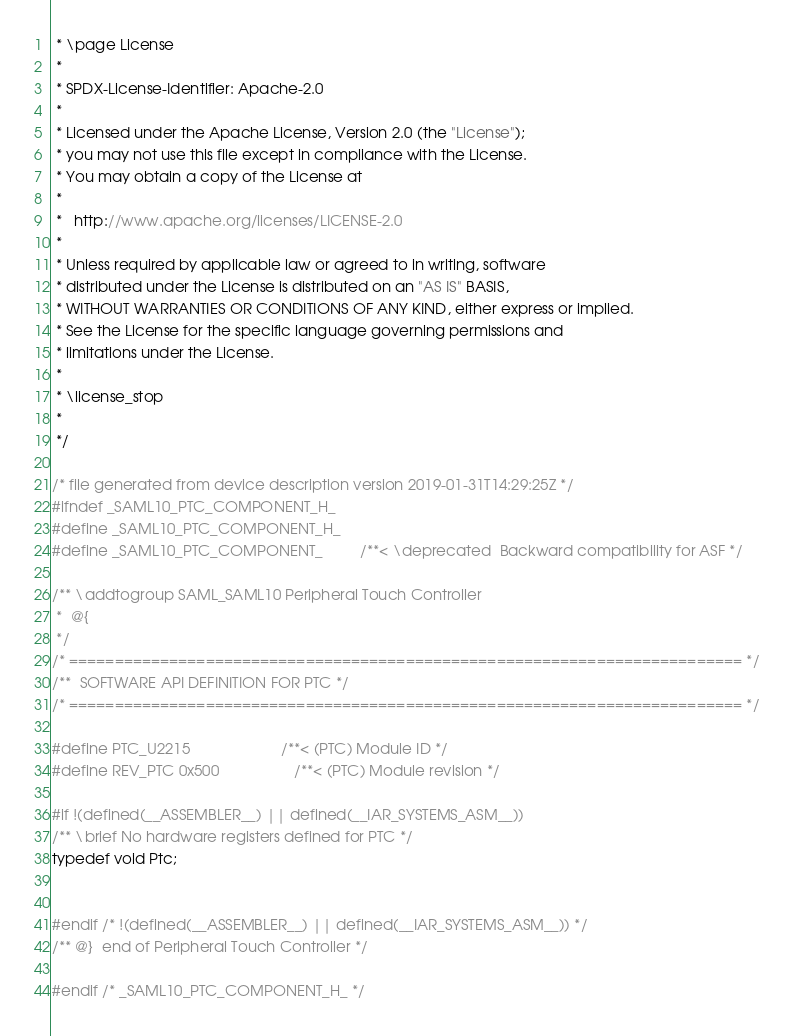Convert code to text. <code><loc_0><loc_0><loc_500><loc_500><_C_> * \page License
 *
 * SPDX-License-Identifier: Apache-2.0
 *
 * Licensed under the Apache License, Version 2.0 (the "License");
 * you may not use this file except in compliance with the License.
 * You may obtain a copy of the License at
 *
 *   http://www.apache.org/licenses/LICENSE-2.0
 *
 * Unless required by applicable law or agreed to in writing, software
 * distributed under the License is distributed on an "AS IS" BASIS,
 * WITHOUT WARRANTIES OR CONDITIONS OF ANY KIND, either express or implied.
 * See the License for the specific language governing permissions and
 * limitations under the License.
 *
 * \license_stop
 *
 */

/* file generated from device description version 2019-01-31T14:29:25Z */
#ifndef _SAML10_PTC_COMPONENT_H_
#define _SAML10_PTC_COMPONENT_H_
#define _SAML10_PTC_COMPONENT_         /**< \deprecated  Backward compatibility for ASF */

/** \addtogroup SAML_SAML10 Peripheral Touch Controller
 *  @{
 */
/* ========================================================================== */
/**  SOFTWARE API DEFINITION FOR PTC */
/* ========================================================================== */

#define PTC_U2215                      /**< (PTC) Module ID */
#define REV_PTC 0x500                  /**< (PTC) Module revision */

#if !(defined(__ASSEMBLER__) || defined(__IAR_SYSTEMS_ASM__))
/** \brief No hardware registers defined for PTC */
typedef void Ptc;


#endif /* !(defined(__ASSEMBLER__) || defined(__IAR_SYSTEMS_ASM__)) */
/** @}  end of Peripheral Touch Controller */

#endif /* _SAML10_PTC_COMPONENT_H_ */
</code> 